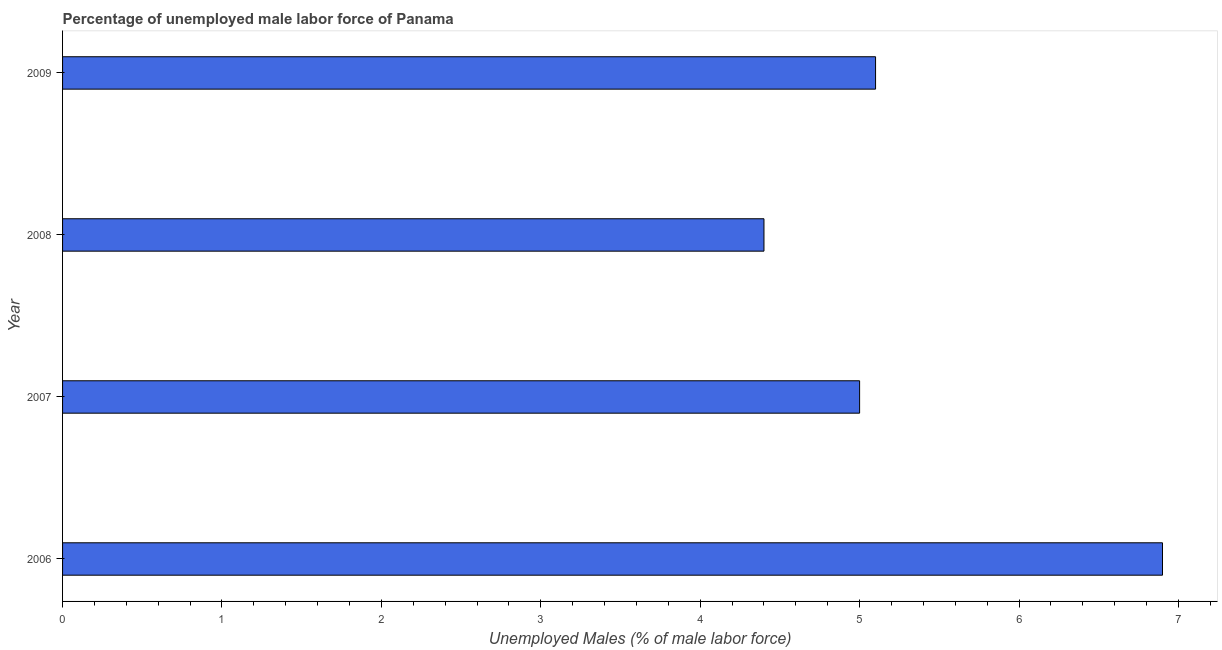Does the graph contain grids?
Keep it short and to the point. No. What is the title of the graph?
Make the answer very short. Percentage of unemployed male labor force of Panama. What is the label or title of the X-axis?
Offer a terse response. Unemployed Males (% of male labor force). What is the total unemployed male labour force in 2008?
Your answer should be very brief. 4.4. Across all years, what is the maximum total unemployed male labour force?
Your answer should be compact. 6.9. Across all years, what is the minimum total unemployed male labour force?
Provide a succinct answer. 4.4. In which year was the total unemployed male labour force maximum?
Provide a succinct answer. 2006. What is the sum of the total unemployed male labour force?
Ensure brevity in your answer.  21.4. What is the average total unemployed male labour force per year?
Offer a terse response. 5.35. What is the median total unemployed male labour force?
Provide a short and direct response. 5.05. Do a majority of the years between 2009 and 2007 (inclusive) have total unemployed male labour force greater than 3 %?
Make the answer very short. Yes. What is the ratio of the total unemployed male labour force in 2006 to that in 2008?
Provide a short and direct response. 1.57. Is the difference between the total unemployed male labour force in 2006 and 2007 greater than the difference between any two years?
Your answer should be very brief. No. Is the sum of the total unemployed male labour force in 2007 and 2009 greater than the maximum total unemployed male labour force across all years?
Provide a short and direct response. Yes. What is the difference between the highest and the lowest total unemployed male labour force?
Keep it short and to the point. 2.5. In how many years, is the total unemployed male labour force greater than the average total unemployed male labour force taken over all years?
Offer a terse response. 1. How many bars are there?
Ensure brevity in your answer.  4. How many years are there in the graph?
Your response must be concise. 4. What is the difference between two consecutive major ticks on the X-axis?
Provide a succinct answer. 1. Are the values on the major ticks of X-axis written in scientific E-notation?
Offer a very short reply. No. What is the Unemployed Males (% of male labor force) of 2006?
Your response must be concise. 6.9. What is the Unemployed Males (% of male labor force) in 2007?
Provide a succinct answer. 5. What is the Unemployed Males (% of male labor force) of 2008?
Offer a very short reply. 4.4. What is the Unemployed Males (% of male labor force) of 2009?
Make the answer very short. 5.1. What is the difference between the Unemployed Males (% of male labor force) in 2006 and 2007?
Your answer should be very brief. 1.9. What is the difference between the Unemployed Males (% of male labor force) in 2006 and 2008?
Ensure brevity in your answer.  2.5. What is the difference between the Unemployed Males (% of male labor force) in 2007 and 2008?
Your answer should be very brief. 0.6. What is the difference between the Unemployed Males (% of male labor force) in 2007 and 2009?
Ensure brevity in your answer.  -0.1. What is the ratio of the Unemployed Males (% of male labor force) in 2006 to that in 2007?
Provide a short and direct response. 1.38. What is the ratio of the Unemployed Males (% of male labor force) in 2006 to that in 2008?
Provide a short and direct response. 1.57. What is the ratio of the Unemployed Males (% of male labor force) in 2006 to that in 2009?
Make the answer very short. 1.35. What is the ratio of the Unemployed Males (% of male labor force) in 2007 to that in 2008?
Provide a short and direct response. 1.14. What is the ratio of the Unemployed Males (% of male labor force) in 2008 to that in 2009?
Provide a succinct answer. 0.86. 